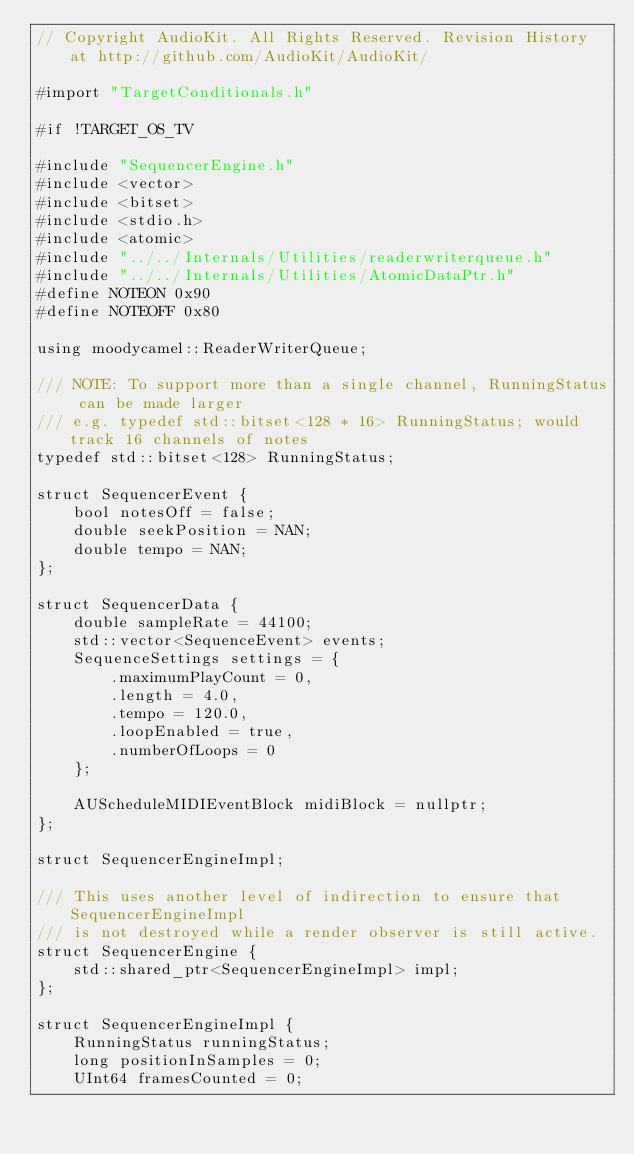<code> <loc_0><loc_0><loc_500><loc_500><_ObjectiveC_>// Copyright AudioKit. All Rights Reserved. Revision History at http://github.com/AudioKit/AudioKit/

#import "TargetConditionals.h"

#if !TARGET_OS_TV

#include "SequencerEngine.h"
#include <vector>
#include <bitset>
#include <stdio.h>
#include <atomic>
#include "../../Internals/Utilities/readerwriterqueue.h"
#include "../../Internals/Utilities/AtomicDataPtr.h"
#define NOTEON 0x90
#define NOTEOFF 0x80

using moodycamel::ReaderWriterQueue;

/// NOTE: To support more than a single channel, RunningStatus can be made larger
/// e.g. typedef std::bitset<128 * 16> RunningStatus; would track 16 channels of notes
typedef std::bitset<128> RunningStatus;

struct SequencerEvent {
    bool notesOff = false;
    double seekPosition = NAN;
    double tempo = NAN;
};

struct SequencerData {
    double sampleRate = 44100;
    std::vector<SequenceEvent> events;
    SequenceSettings settings = {
        .maximumPlayCount = 0,
        .length = 4.0,
        .tempo = 120.0,
        .loopEnabled = true,
        .numberOfLoops = 0
    };

    AUScheduleMIDIEventBlock midiBlock = nullptr;
};

struct SequencerEngineImpl;

/// This uses another level of indirection to ensure that SequencerEngineImpl
/// is not destroyed while a render observer is still active.
struct SequencerEngine {
    std::shared_ptr<SequencerEngineImpl> impl;
};

struct SequencerEngineImpl {
    RunningStatus runningStatus;
    long positionInSamples = 0;
    UInt64 framesCounted = 0;</code> 